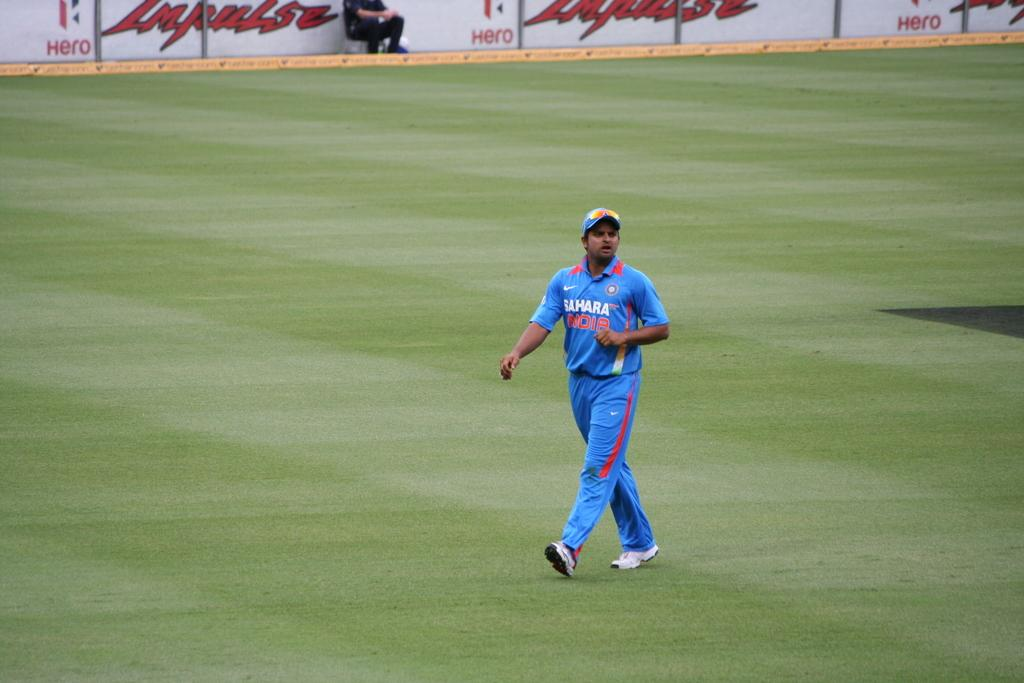<image>
Render a clear and concise summary of the photo. A blue and red baseball player has the logo for Sahara on their chest. 